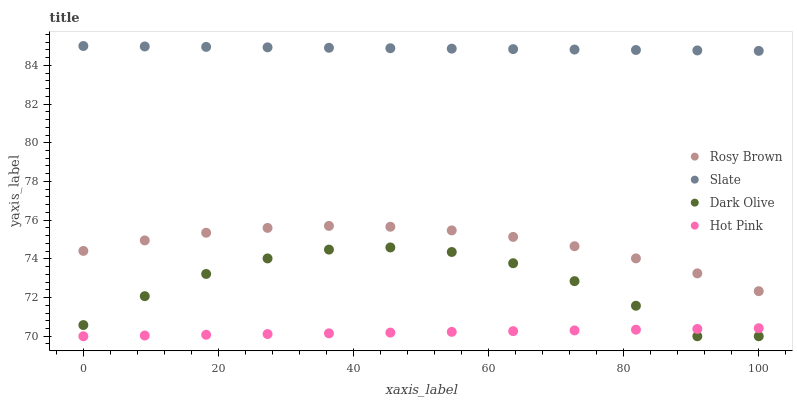Does Hot Pink have the minimum area under the curve?
Answer yes or no. Yes. Does Slate have the maximum area under the curve?
Answer yes or no. Yes. Does Rosy Brown have the minimum area under the curve?
Answer yes or no. No. Does Rosy Brown have the maximum area under the curve?
Answer yes or no. No. Is Slate the smoothest?
Answer yes or no. Yes. Is Dark Olive the roughest?
Answer yes or no. Yes. Is Rosy Brown the smoothest?
Answer yes or no. No. Is Rosy Brown the roughest?
Answer yes or no. No. Does Dark Olive have the lowest value?
Answer yes or no. Yes. Does Rosy Brown have the lowest value?
Answer yes or no. No. Does Slate have the highest value?
Answer yes or no. Yes. Does Rosy Brown have the highest value?
Answer yes or no. No. Is Rosy Brown less than Slate?
Answer yes or no. Yes. Is Rosy Brown greater than Dark Olive?
Answer yes or no. Yes. Does Hot Pink intersect Dark Olive?
Answer yes or no. Yes. Is Hot Pink less than Dark Olive?
Answer yes or no. No. Is Hot Pink greater than Dark Olive?
Answer yes or no. No. Does Rosy Brown intersect Slate?
Answer yes or no. No. 